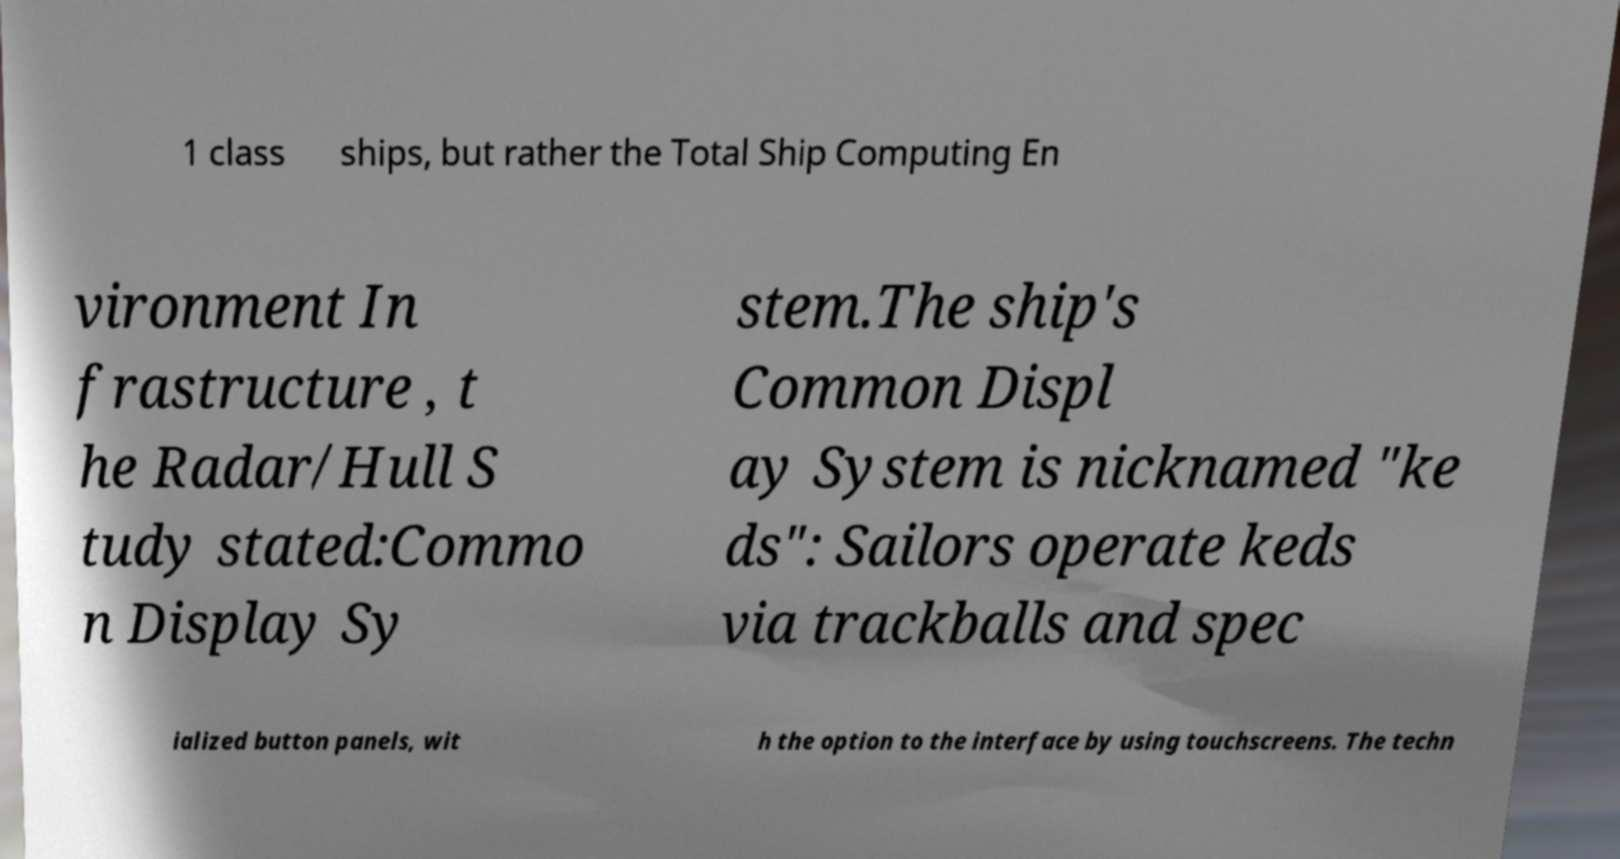Please identify and transcribe the text found in this image. 1 class ships, but rather the Total Ship Computing En vironment In frastructure , t he Radar/Hull S tudy stated:Commo n Display Sy stem.The ship's Common Displ ay System is nicknamed "ke ds": Sailors operate keds via trackballs and spec ialized button panels, wit h the option to the interface by using touchscreens. The techn 